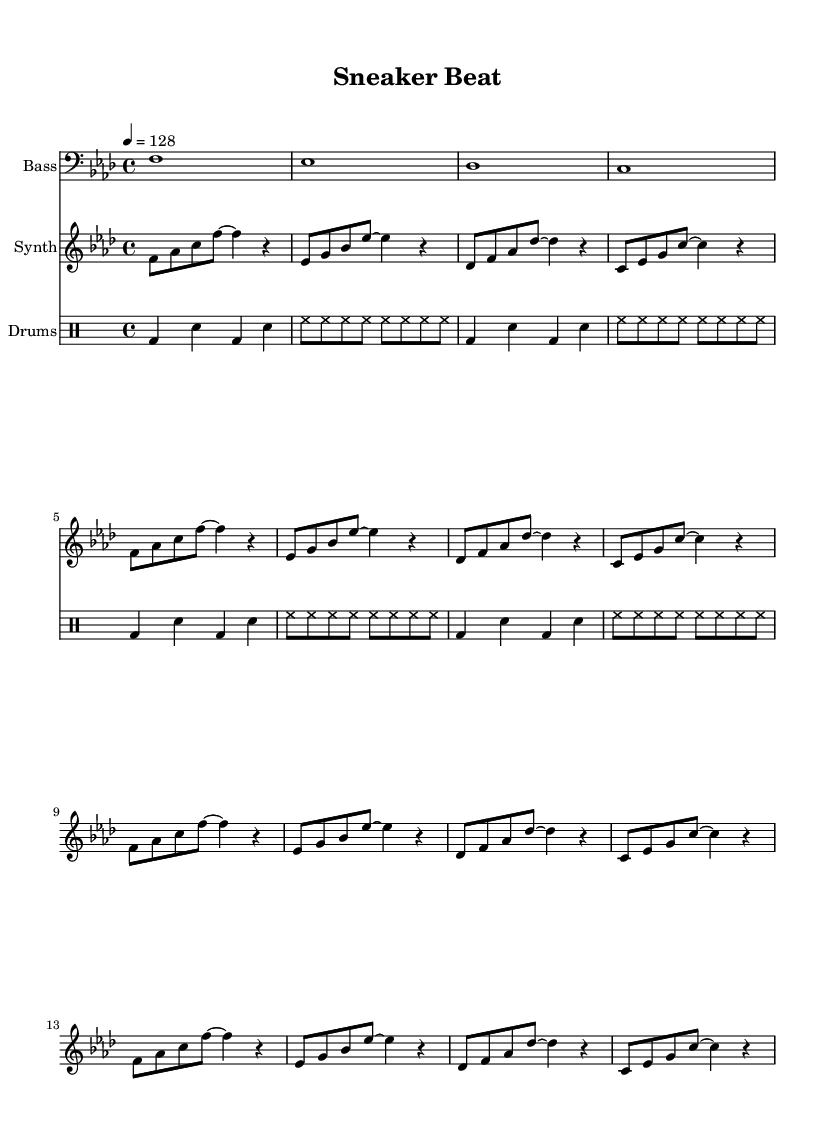What is the key signature of this music? The key signature is indicated by the flats at the beginning of the staff. In this case, there are six flats, which corresponds to the key of F minor.
Answer: F minor What is the time signature of this music? The time signature is shown at the beginning of the score, and it reads 4/4, meaning there are four beats in each measure and the quarter note gets one beat.
Answer: 4/4 What is the tempo marking for this music? The tempo is indicated in the tempo text, which shows a quarter note equals 128 beats per minute. This signifies how fast the music should be played.
Answer: 128 How many measures does the synth part have? The synth part has a repeated section that occurs four times, which includes a total of four measures within each repetition, leading to 16 measures overall.
Answer: 16 What percussion elements are included in this piece? The drum portion is defined using standard drum notation, where "bd" refers to bass drum and "sn" refers to snare drum, which are common elements in house music.
Answer: Bass drum and snare drum What is the rhythmic feel of the bass part? The bass part has whole notes, representing sustained notes evenly across four beats in each measure, contributing to the overall groove typical of house music.
Answer: Whole notes What genre does this piece belong to? The style and structure of the music, along with the use of synthesizers and a steady beat, categorizes it clearly as a funky house genre, often incorporating samples and rhythmic grooves.
Answer: Funky house 